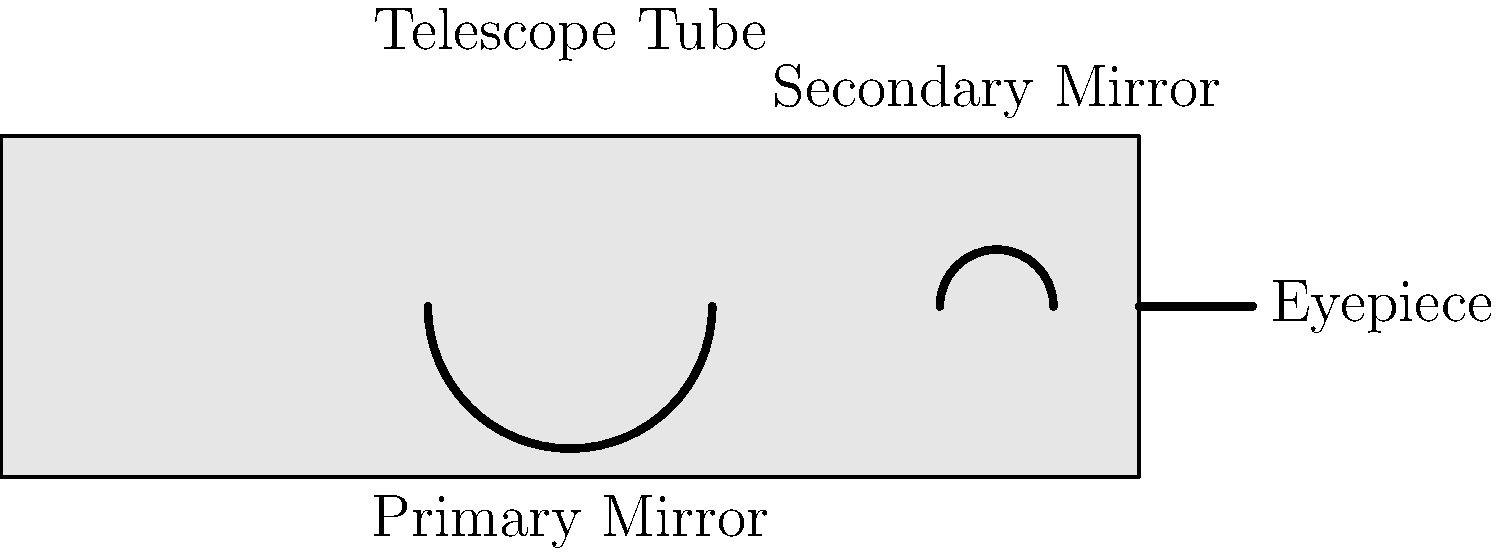As a parent proud of your child's achievements in computer science, you want to expand your knowledge of astronomy to support their interests. Identify the component in a reflecting telescope that collects and focuses the incoming light, as shown in the diagram. To answer this question, let's break down the main components of a reflecting telescope:

1. Telescope Tube: This is the main body of the telescope that houses all the optical components.

2. Primary Mirror: Located at the back of the telescope tube, this is a large concave mirror that collects and reflects incoming light.

3. Secondary Mirror: A smaller mirror near the front of the tube that reflects the light from the primary mirror towards the eyepiece.

4. Eyepiece: Where the observer looks through to see the magnified image.

The component responsible for collecting and focusing the incoming light is the Primary Mirror. It's the largest optical element in the telescope and serves two crucial functions:

a) Collecting light: Its large surface area allows it to gather more light than the human eye, making faint objects visible.

b) Focusing light: Its concave shape focuses the collected light to a single point, creating a clear image.

The primary mirror reflects the light to the secondary mirror, which then directs it to the eyepiece for viewing. Without the primary mirror, the telescope wouldn't be able to gather enough light or focus it properly to create a clear, magnified image of distant celestial objects.
Answer: Primary Mirror 